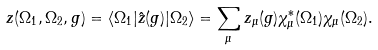<formula> <loc_0><loc_0><loc_500><loc_500>z ( \Omega _ { 1 } , \Omega _ { 2 } , g ) = \langle \Omega _ { 1 } | \hat { z } ( g ) | \Omega _ { 2 } \rangle = \sum _ { \mu } z _ { \mu } ( g ) \chi ^ { * } _ { \mu } ( \Omega _ { 1 } ) \chi _ { \mu } ( \Omega _ { 2 } ) .</formula> 